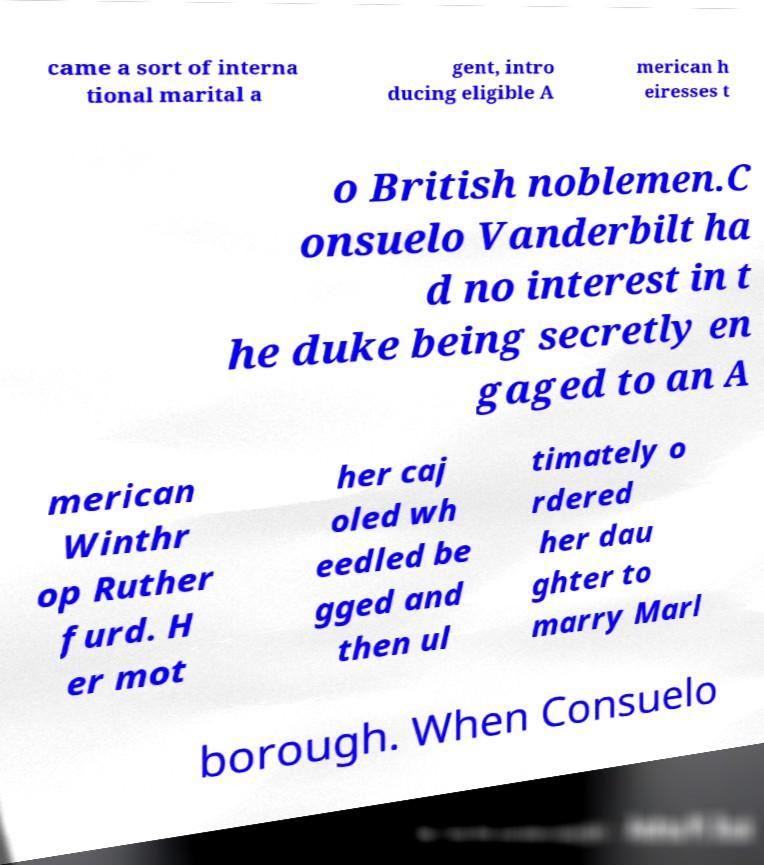Can you read and provide the text displayed in the image?This photo seems to have some interesting text. Can you extract and type it out for me? came a sort of interna tional marital a gent, intro ducing eligible A merican h eiresses t o British noblemen.C onsuelo Vanderbilt ha d no interest in t he duke being secretly en gaged to an A merican Winthr op Ruther furd. H er mot her caj oled wh eedled be gged and then ul timately o rdered her dau ghter to marry Marl borough. When Consuelo 